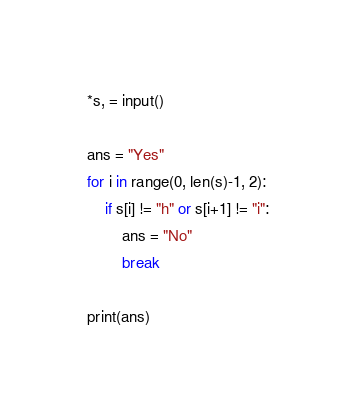<code> <loc_0><loc_0><loc_500><loc_500><_Python_>*s, = input()

ans = "Yes"
for i in range(0, len(s)-1, 2):
    if s[i] != "h" or s[i+1] != "i":
        ans = "No"
        break

print(ans)
</code> 